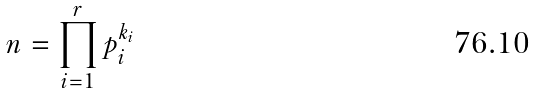<formula> <loc_0><loc_0><loc_500><loc_500>n = \prod _ { i = 1 } ^ { r } p _ { i } ^ { k _ { i } }</formula> 